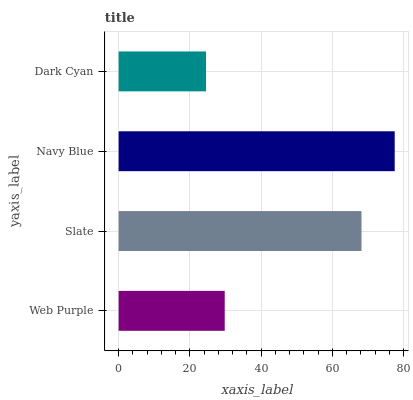Is Dark Cyan the minimum?
Answer yes or no. Yes. Is Navy Blue the maximum?
Answer yes or no. Yes. Is Slate the minimum?
Answer yes or no. No. Is Slate the maximum?
Answer yes or no. No. Is Slate greater than Web Purple?
Answer yes or no. Yes. Is Web Purple less than Slate?
Answer yes or no. Yes. Is Web Purple greater than Slate?
Answer yes or no. No. Is Slate less than Web Purple?
Answer yes or no. No. Is Slate the high median?
Answer yes or no. Yes. Is Web Purple the low median?
Answer yes or no. Yes. Is Web Purple the high median?
Answer yes or no. No. Is Slate the low median?
Answer yes or no. No. 